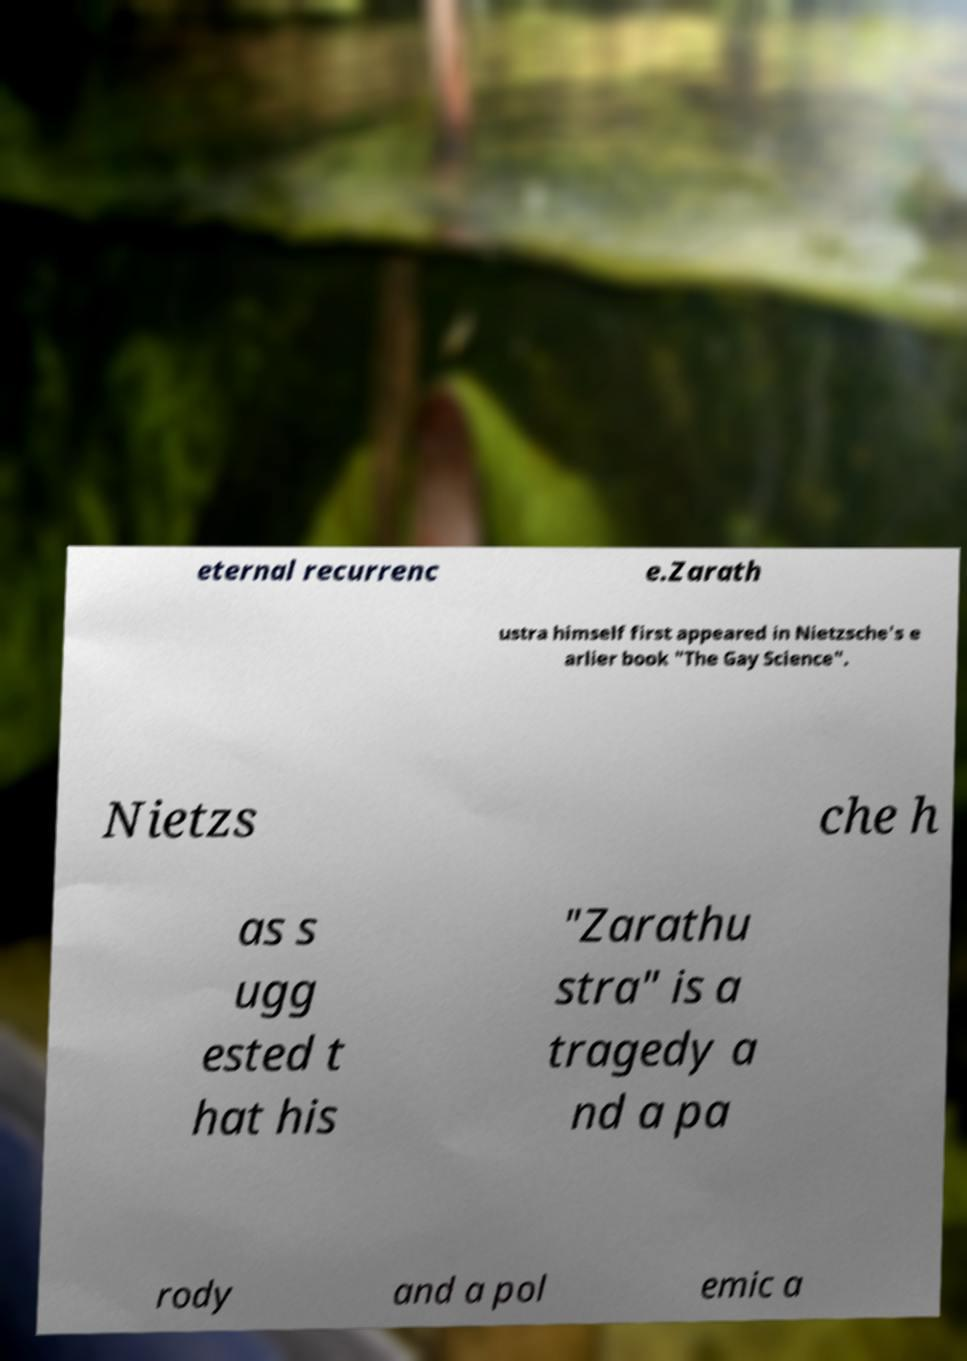What messages or text are displayed in this image? I need them in a readable, typed format. eternal recurrenc e.Zarath ustra himself first appeared in Nietzsche's e arlier book "The Gay Science". Nietzs che h as s ugg ested t hat his "Zarathu stra" is a tragedy a nd a pa rody and a pol emic a 